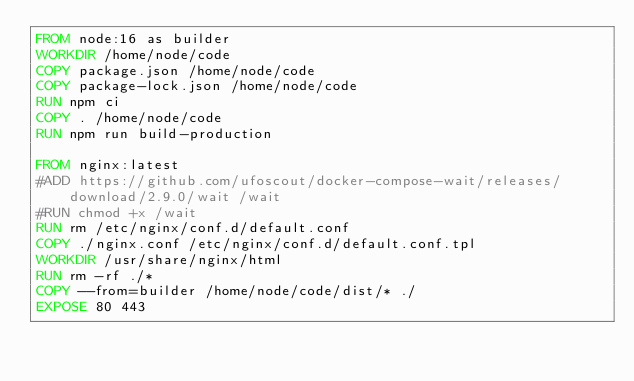Convert code to text. <code><loc_0><loc_0><loc_500><loc_500><_Dockerfile_>FROM node:16 as builder
WORKDIR /home/node/code
COPY package.json /home/node/code
COPY package-lock.json /home/node/code
RUN npm ci
COPY . /home/node/code
RUN npm run build-production

FROM nginx:latest
#ADD https://github.com/ufoscout/docker-compose-wait/releases/download/2.9.0/wait /wait
#RUN chmod +x /wait
RUN rm /etc/nginx/conf.d/default.conf
COPY ./nginx.conf /etc/nginx/conf.d/default.conf.tpl
WORKDIR /usr/share/nginx/html
RUN rm -rf ./*
COPY --from=builder /home/node/code/dist/* ./
EXPOSE 80 443</code> 